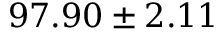Convert formula to latex. <formula><loc_0><loc_0><loc_500><loc_500>9 7 . 9 0 \pm 2 . 1 1 \</formula> 